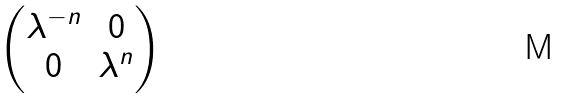<formula> <loc_0><loc_0><loc_500><loc_500>\begin{pmatrix} \lambda ^ { - n } & 0 \\ 0 & \lambda ^ { n } \end{pmatrix}</formula> 